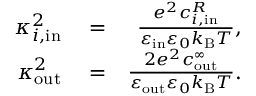<formula> <loc_0><loc_0><loc_500><loc_500>\begin{array} { r l r } { \kappa _ { i , i n } ^ { 2 } } & = } & { \frac { e ^ { 2 } c _ { i , i n } ^ { R } } { \varepsilon _ { i n } \varepsilon _ { 0 } k _ { B } T } , } \\ { \kappa _ { o u t } ^ { 2 } } & = } & { \frac { 2 e ^ { 2 } c _ { o u t } ^ { \infty } } { \varepsilon _ { o u t } \varepsilon _ { 0 } k _ { B } T } . } \end{array}</formula> 